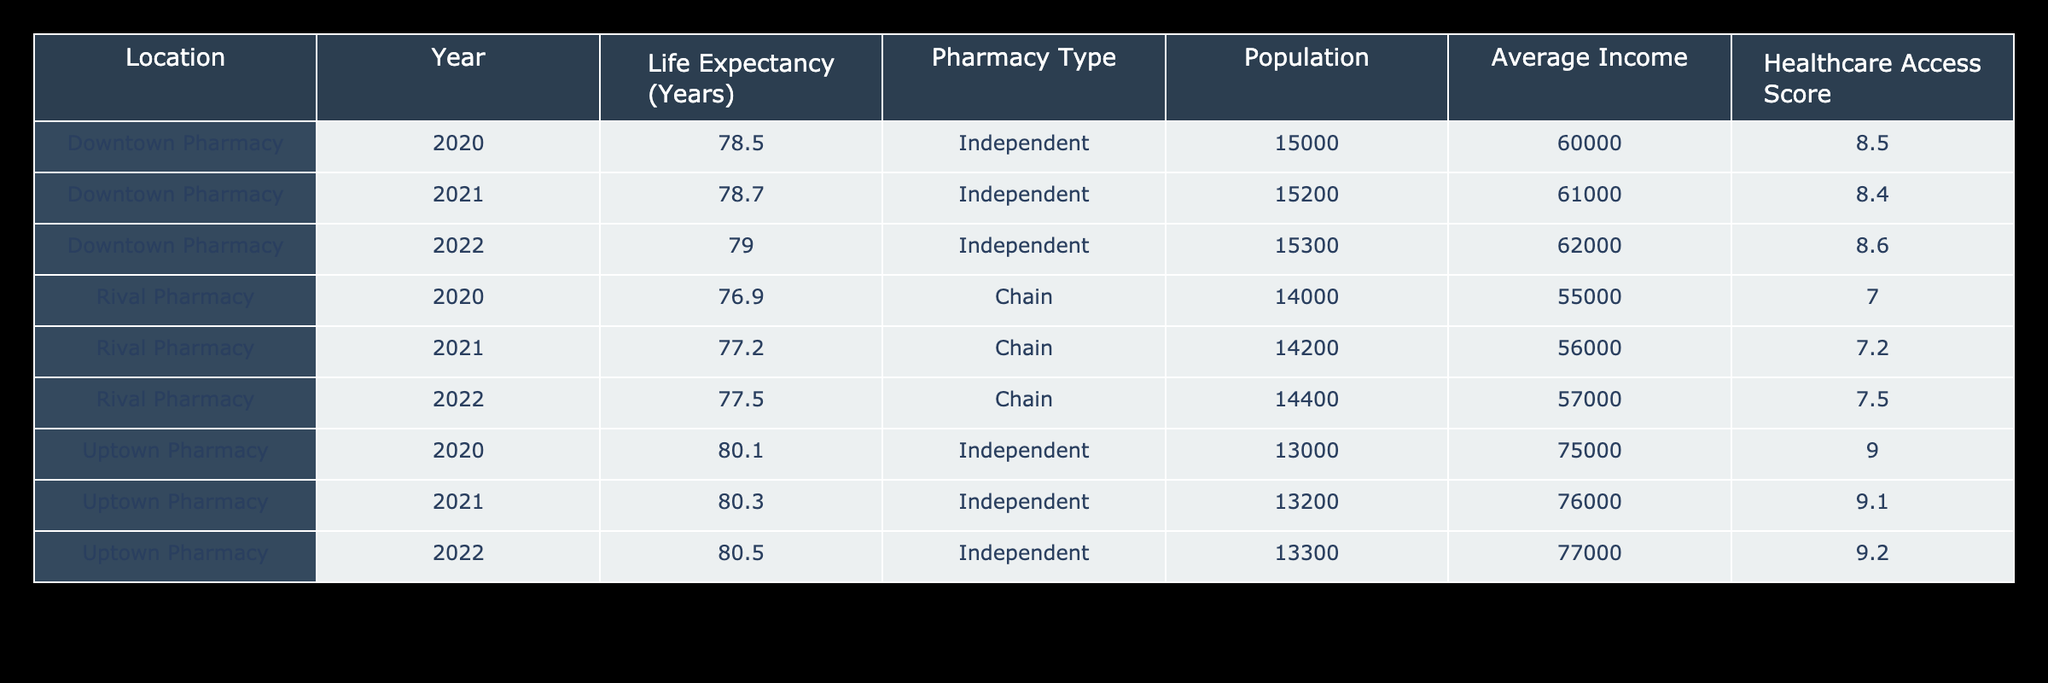What is the life expectancy at Downtown Pharmacy in 2021? The table shows that the life expectancy for Downtown Pharmacy in 2021 is listed directly as 78.7 years.
Answer: 78.7 What was the average life expectancy for the Rival Pharmacy from 2020 to 2022? To find the average, add the life expectancies for those years: 76.9 (2020) + 77.2 (2021) + 77.5 (2022) = 231.6. Divide by 3 (the number of years): 231.6 / 3 = 77.2
Answer: 77.2 Is the average income at Uptown Pharmacy higher than that at Downtown Pharmacy in 2020? The average income for Uptown Pharmacy in 2020 is 75,000 while for Downtown Pharmacy it is 60,000. Since 75,000 is greater than 60,000, the statement is true.
Answer: Yes What was the life expectancy trend for the Downtown Pharmacy from 2020 to 2022? The life expectancy increased from 78.5 in 2020 to 78.7 in 2021, then to 79.0 in 2022. Thus, the trend shows a consistent increase over these years.
Answer: Increasing What is the difference in life expectancy between Uptown Pharmacy and Rival Pharmacy in 2022? The life expectancy for Uptown Pharmacy in 2022 is 80.5, and for Rival Pharmacy, it is 77.5. The difference is calculated by subtracting 77.5 from 80.5: 80.5 - 77.5 = 3.0.
Answer: 3.0 Was the healthcare access score at the rival pharmacy higher or lower than that at the Uptown Pharmacy in 2021? The healthcare access score for the rival pharmacy in 2021 is 7.2, while for Uptown Pharmacy, it is 9.1. Since 7.2 is less than 9.1, the rival pharmacy's score was lower.
Answer: Lower What is the total population served by the Downtown Pharmacy over the years provided? The populations for Downtown Pharmacy are: 15,000 (2020), 15,200 (2021), and 15,300 (2022). Adding these: 15,000 + 15,200 + 15,300 = 45,500.
Answer: 45,500 Does the life expectancy trend for Uptown Pharmacy show any decrease from 2020 to 2022? The life expectancy for Uptown Pharmacy increased from 80.1 in 2020, to 80.3 in 2021, and to 80.5 in 2022. Therefore, there is no decrease in the trend.
Answer: No What was the average healthcare access score for all pharmacies from 2020 to 2022? The healthcare access scores are: Downtown Pharmacy: 8.5, 8.4, 8.6; Rival Pharmacy: 7.0, 7.2, 7.5; Uptown Pharmacy: 9.0, 9.1, 9.2. The total score is 8.5 + 8.4 + 8.6 + 7.0 + 7.2 + 7.5 + 9.0 + 9.1 + 9.2 = 74.5. There are 9 scores, so the average is 74.5 / 9 = 8.28.
Answer: 8.28 